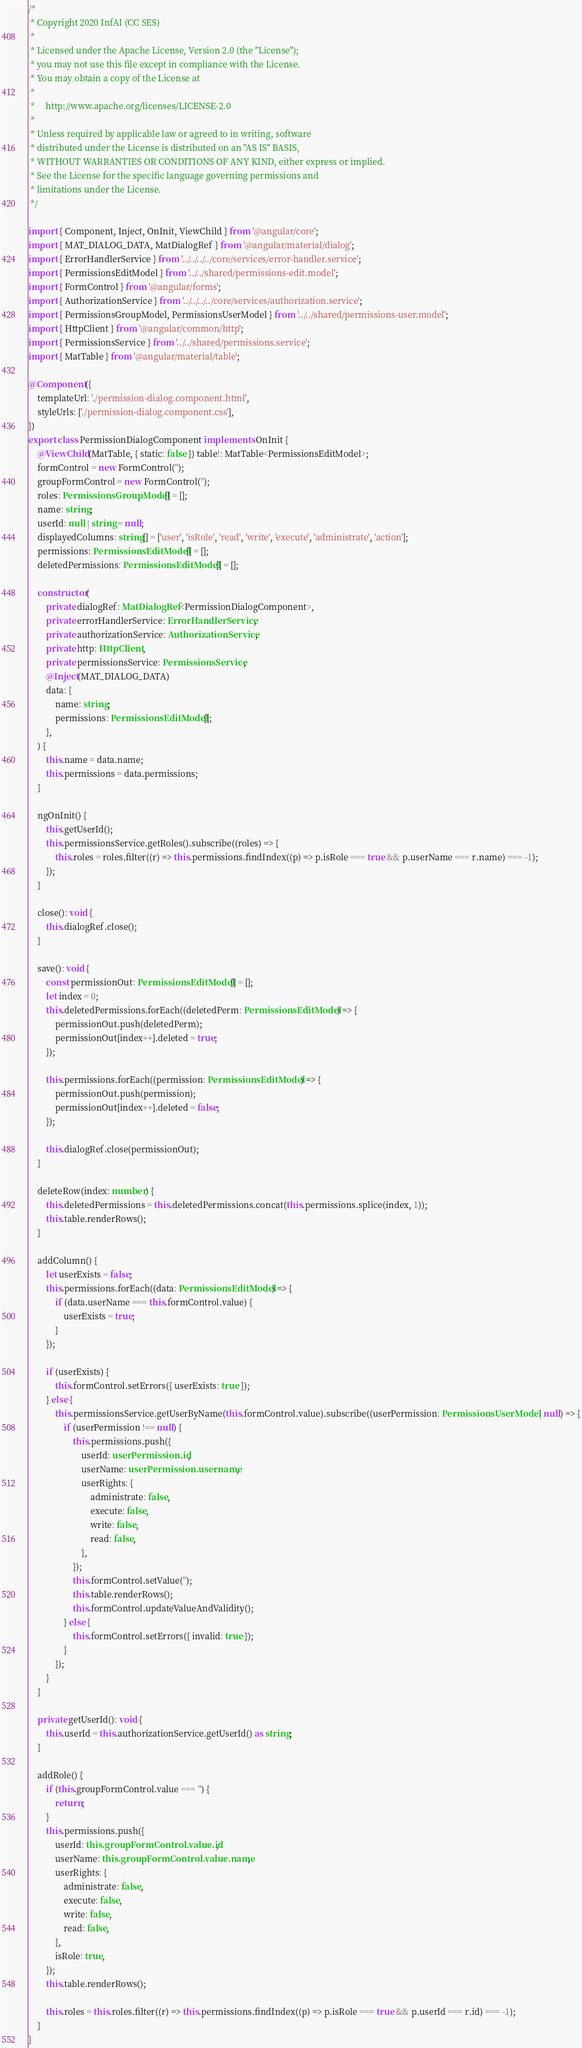Convert code to text. <code><loc_0><loc_0><loc_500><loc_500><_TypeScript_>/*
 * Copyright 2020 InfAI (CC SES)
 *
 * Licensed under the Apache License, Version 2.0 (the "License");
 * you may not use this file except in compliance with the License.
 * You may obtain a copy of the License at
 *
 *     http://www.apache.org/licenses/LICENSE-2.0
 *
 * Unless required by applicable law or agreed to in writing, software
 * distributed under the License is distributed on an "AS IS" BASIS,
 * WITHOUT WARRANTIES OR CONDITIONS OF ANY KIND, either express or implied.
 * See the License for the specific language governing permissions and
 * limitations under the License.
 */

import { Component, Inject, OnInit, ViewChild } from '@angular/core';
import { MAT_DIALOG_DATA, MatDialogRef } from '@angular/material/dialog';
import { ErrorHandlerService } from '../../../../core/services/error-handler.service';
import { PermissionsEditModel } from '../../shared/permissions-edit.model';
import { FormControl } from '@angular/forms';
import { AuthorizationService } from '../../../../core/services/authorization.service';
import { PermissionsGroupModel, PermissionsUserModel } from '../../shared/permissions-user.model';
import { HttpClient } from '@angular/common/http';
import { PermissionsService } from '../../shared/permissions.service';
import { MatTable } from '@angular/material/table';

@Component({
    templateUrl: './permission-dialog.component.html',
    styleUrls: ['./permission-dialog.component.css'],
})
export class PermissionDialogComponent implements OnInit {
    @ViewChild(MatTable, { static: false }) table!: MatTable<PermissionsEditModel>;
    formControl = new FormControl('');
    groupFormControl = new FormControl('');
    roles: PermissionsGroupModel[] = [];
    name: string;
    userId: null | string = null;
    displayedColumns: string[] = ['user', 'isRole', 'read', 'write', 'execute', 'administrate', 'action'];
    permissions: PermissionsEditModel[] = [];
    deletedPermissions: PermissionsEditModel[] = [];

    constructor(
        private dialogRef: MatDialogRef<PermissionDialogComponent>,
        private errorHandlerService: ErrorHandlerService,
        private authorizationService: AuthorizationService,
        private http: HttpClient,
        private permissionsService: PermissionsService,
        @Inject(MAT_DIALOG_DATA)
        data: {
            name: string;
            permissions: PermissionsEditModel[];
        },
    ) {
        this.name = data.name;
        this.permissions = data.permissions;
    }

    ngOnInit() {
        this.getUserId();
        this.permissionsService.getRoles().subscribe((roles) => {
            this.roles = roles.filter((r) => this.permissions.findIndex((p) => p.isRole === true && p.userName === r.name) === -1);
        });
    }

    close(): void {
        this.dialogRef.close();
    }

    save(): void {
        const permissionOut: PermissionsEditModel[] = [];
        let index = 0;
        this.deletedPermissions.forEach((deletedPerm: PermissionsEditModel) => {
            permissionOut.push(deletedPerm);
            permissionOut[index++].deleted = true;
        });

        this.permissions.forEach((permission: PermissionsEditModel) => {
            permissionOut.push(permission);
            permissionOut[index++].deleted = false;
        });

        this.dialogRef.close(permissionOut);
    }

    deleteRow(index: number) {
        this.deletedPermissions = this.deletedPermissions.concat(this.permissions.splice(index, 1));
        this.table.renderRows();
    }

    addColumn() {
        let userExists = false;
        this.permissions.forEach((data: PermissionsEditModel) => {
            if (data.userName === this.formControl.value) {
                userExists = true;
            }
        });

        if (userExists) {
            this.formControl.setErrors({ userExists: true });
        } else {
            this.permissionsService.getUserByName(this.formControl.value).subscribe((userPermission: PermissionsUserModel | null) => {
                if (userPermission !== null) {
                    this.permissions.push({
                        userId: userPermission.id,
                        userName: userPermission.username,
                        userRights: {
                            administrate: false,
                            execute: false,
                            write: false,
                            read: false,
                        },
                    });
                    this.formControl.setValue('');
                    this.table.renderRows();
                    this.formControl.updateValueAndValidity();
                } else {
                    this.formControl.setErrors({ invalid: true });
                }
            });
        }
    }

    private getUserId(): void {
        this.userId = this.authorizationService.getUserId() as string;
    }

    addRole() {
        if (this.groupFormControl.value === '') {
            return;
        }
        this.permissions.push({
            userId: this.groupFormControl.value.id,
            userName: this.groupFormControl.value.name,
            userRights: {
                administrate: false,
                execute: false,
                write: false,
                read: false,
            },
            isRole: true,
        });
        this.table.renderRows();

        this.roles = this.roles.filter((r) => this.permissions.findIndex((p) => p.isRole === true && p.userId === r.id) === -1);
    }
}
</code> 